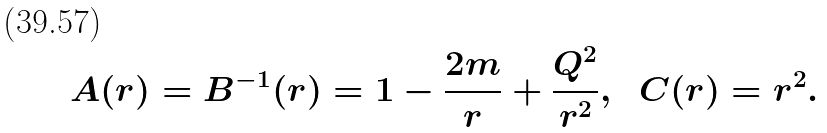Convert formula to latex. <formula><loc_0><loc_0><loc_500><loc_500>A ( r ) = B ^ { - 1 } ( r ) = 1 - \frac { 2 m } { r } + \frac { Q ^ { 2 } } { r ^ { 2 } } , \ \ C ( r ) = r ^ { 2 } .</formula> 